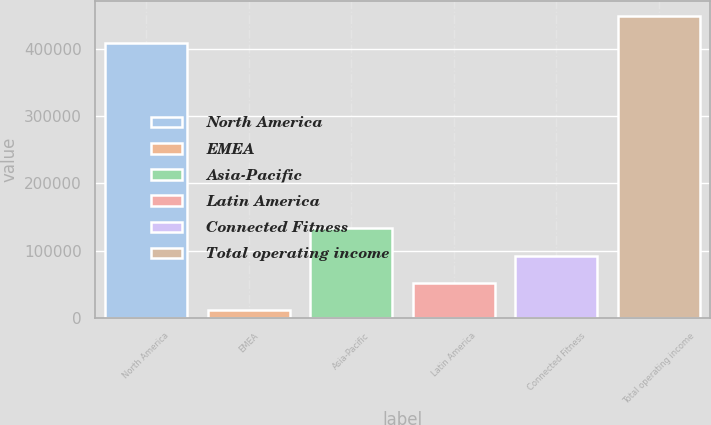Convert chart. <chart><loc_0><loc_0><loc_500><loc_500><bar_chart><fcel>North America<fcel>EMEA<fcel>Asia-Pacific<fcel>Latin America<fcel>Connected Fitness<fcel>Total operating income<nl><fcel>408424<fcel>11420<fcel>133235<fcel>52025.1<fcel>92630.2<fcel>449029<nl></chart> 